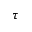Convert formula to latex. <formula><loc_0><loc_0><loc_500><loc_500>\tau</formula> 